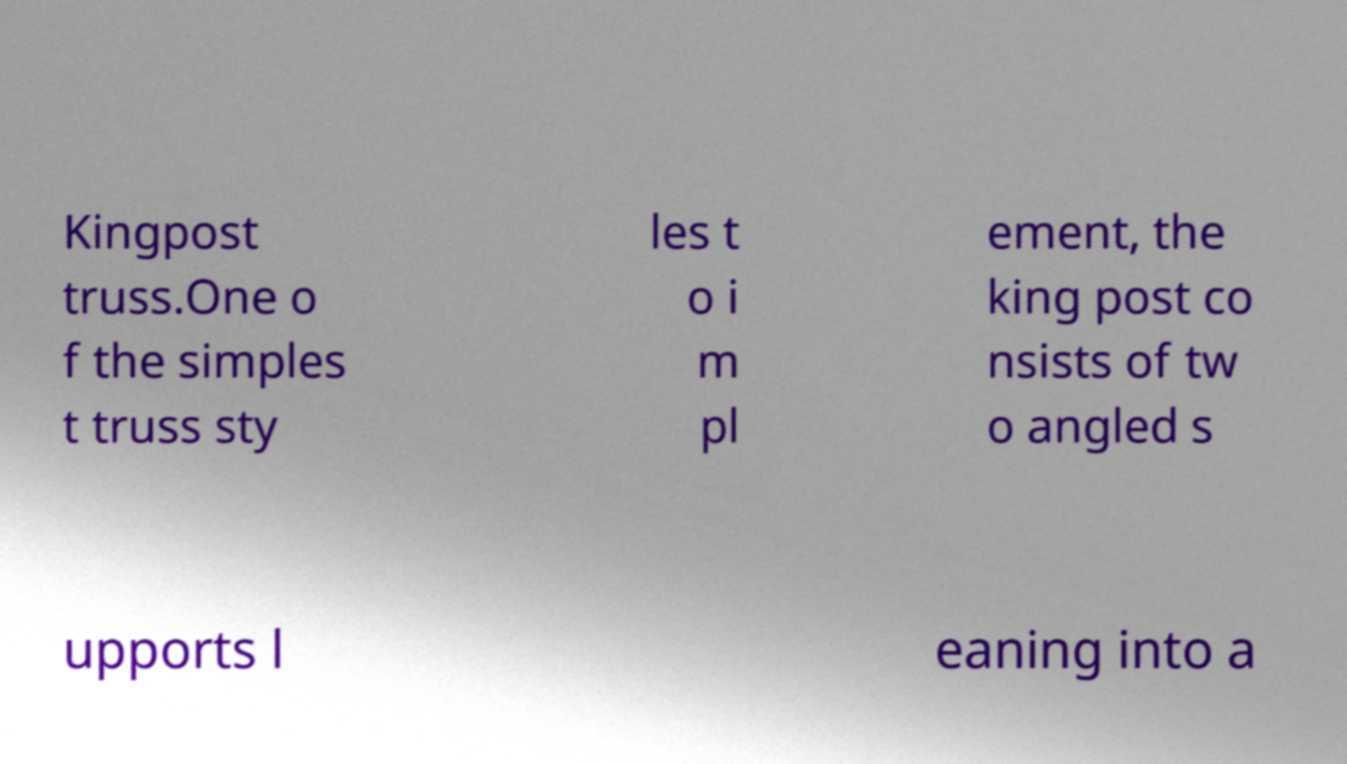What messages or text are displayed in this image? I need them in a readable, typed format. Kingpost truss.One o f the simples t truss sty les t o i m pl ement, the king post co nsists of tw o angled s upports l eaning into a 